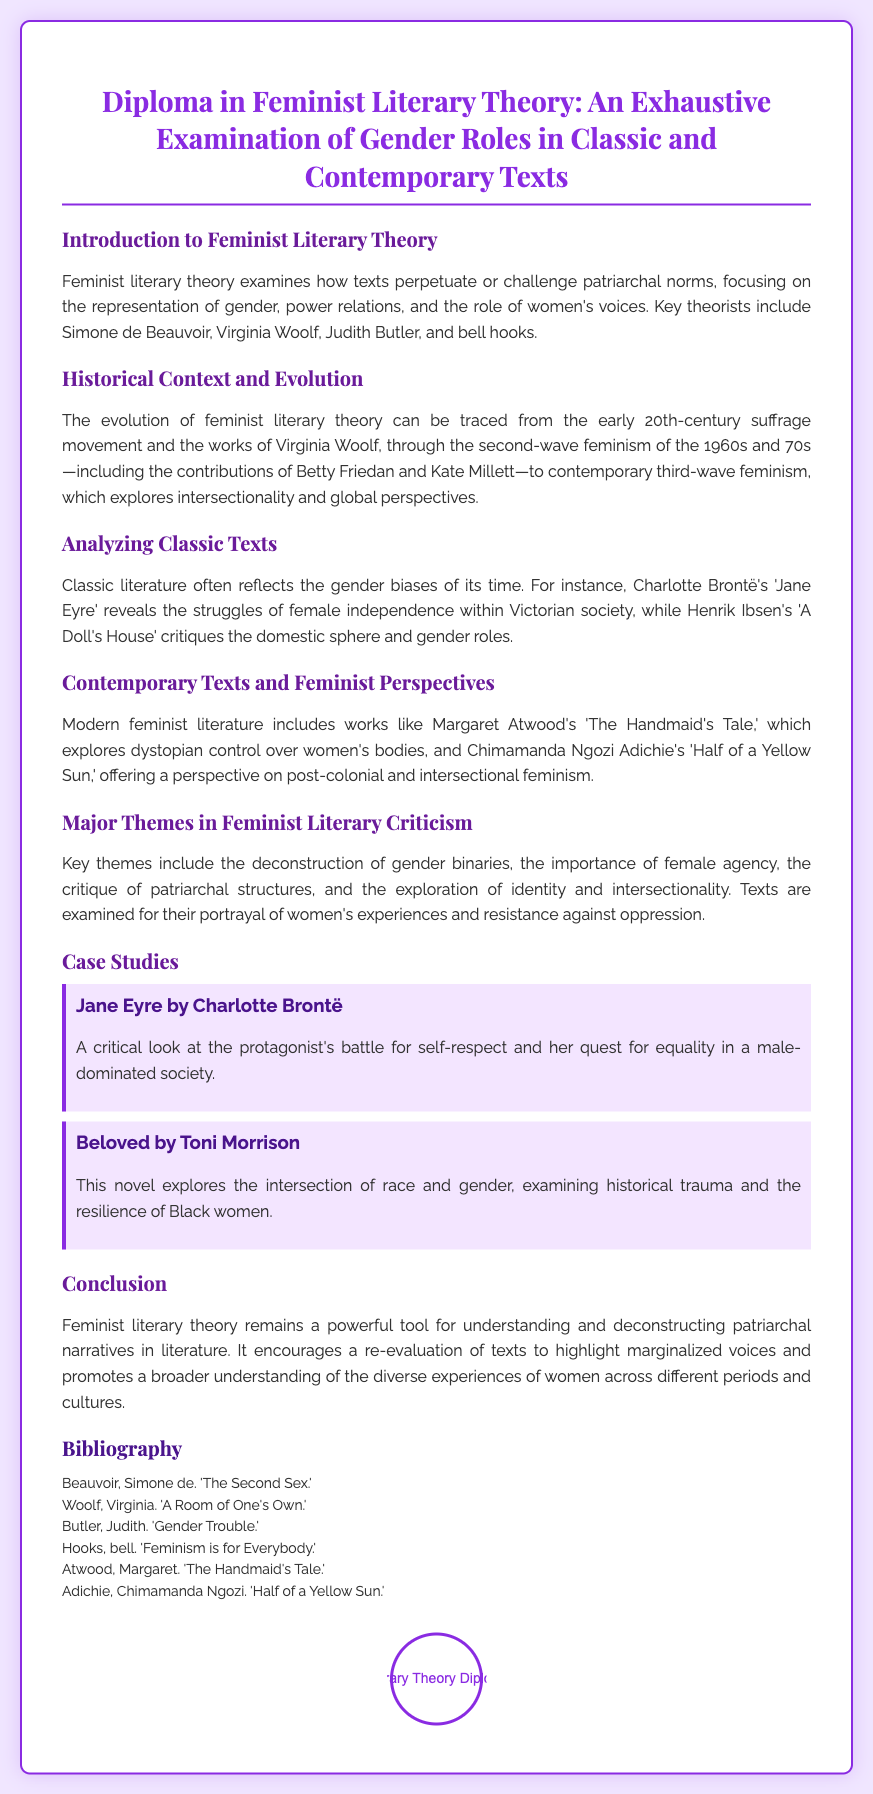What is the title of the diploma? The title of the diploma is presented prominently at the top of the document.
Answer: Diploma in Feminist Literary Theory: An Exhaustive Examination of Gender Roles in Classic and Contemporary Texts Who is one of the key theorists mentioned? The document lists key theorists involved in feminist literary theory.
Answer: Simone de Beauvoir What is a major theme in feminist literary criticism? The document outlines key themes within feminist literary criticism.
Answer: Deconstruction of gender binaries Which classic text is analyzed for female independence? The document gives examples of classic texts that reflect gender issues.
Answer: Jane Eyre What contemporary text explores dystopian control over women's bodies? The document includes examples of modern feminist literature and their themes.
Answer: The Handmaid's Tale What year range does the second-wave feminism refer to? The document specifies a time frame for second-wave feminism and its notable contributors.
Answer: 1960s and 70s Name one author included in the bibliography. The bibliography lists works and their authors relevant to feminist literary theory.
Answer: Virginia Woolf How is the case study of "Beloved" characterized? The document describes case studies focusing on specific themes and texts.
Answer: Intersection of race and gender What is the background color of the diploma? The overall design and color scheme of the diploma are described.
Answer: #f0e6ff 